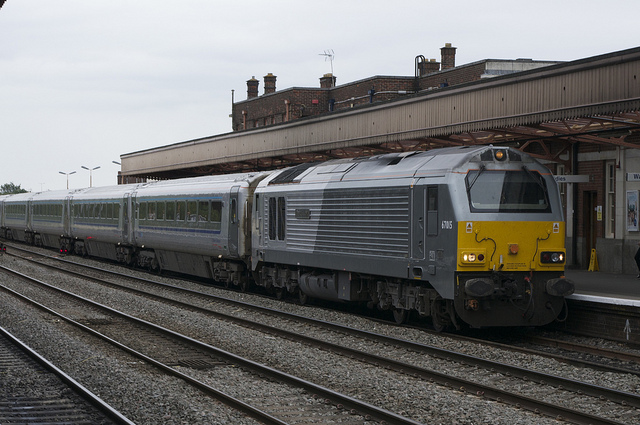Describe the setting around the train. The train is at a station with a classic design featuring a platform canopy and a building with distinct architectural details. There are various signal lights and signs, indicative of an operational and potentially busy train station. The presence of multiple tracks suggests it's a station of some significance, potentially a stop on a major route or a junction. 